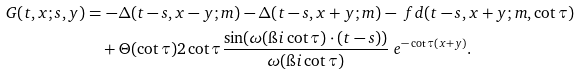<formula> <loc_0><loc_0><loc_500><loc_500>G ( t , x ; s , y ) & = - \Delta ( t - s , x - y ; m ) - \Delta ( t - s , x + y ; m ) - \ f d ( t - s , x + y ; m , \cot \tau ) \\ & \quad + \Theta ( \cot \tau ) { 2 \cot \tau } \frac { \sin ( \omega ( \i i \cot \tau ) \cdot ( t - s ) ) } { \omega ( \i i \cot \tau ) } \ e ^ { - \cot \tau ( x + y ) } .</formula> 